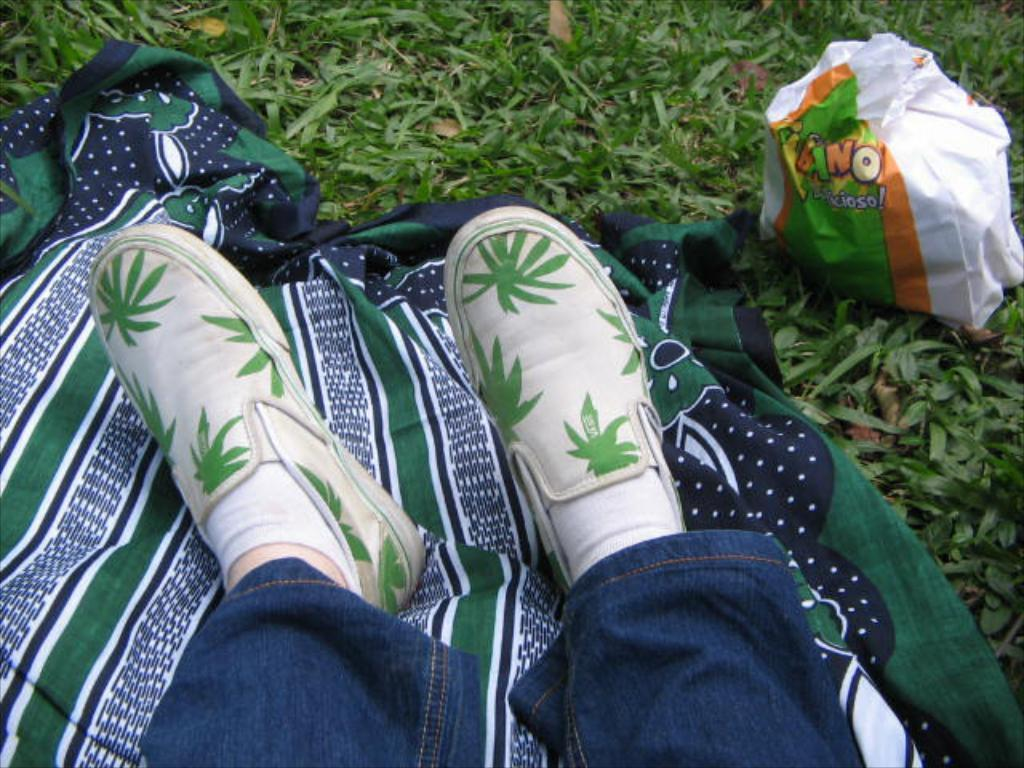What object is present in the image that might be used for carrying items? There is a paper bag in the image. What type of natural environment is visible in the image? There is grass in the image. What type of material is covering the ground in the image? There is a cloth on the ground in the image. Whose legs are visible in the image? Human legs are visible in the image. What type of bead is being used for learning in the image? There is no bead or learning activity present in the image. What impulse is driving the actions of the person in the image? There is no indication of the person's impulses or motivations in the image. 